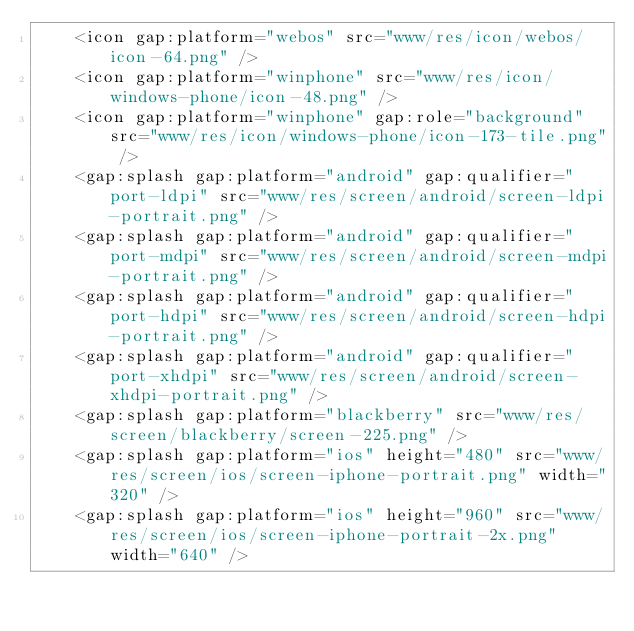<code> <loc_0><loc_0><loc_500><loc_500><_XML_>    <icon gap:platform="webos" src="www/res/icon/webos/icon-64.png" />
    <icon gap:platform="winphone" src="www/res/icon/windows-phone/icon-48.png" />
    <icon gap:platform="winphone" gap:role="background" src="www/res/icon/windows-phone/icon-173-tile.png" />
    <gap:splash gap:platform="android" gap:qualifier="port-ldpi" src="www/res/screen/android/screen-ldpi-portrait.png" />
    <gap:splash gap:platform="android" gap:qualifier="port-mdpi" src="www/res/screen/android/screen-mdpi-portrait.png" />
    <gap:splash gap:platform="android" gap:qualifier="port-hdpi" src="www/res/screen/android/screen-hdpi-portrait.png" />
    <gap:splash gap:platform="android" gap:qualifier="port-xhdpi" src="www/res/screen/android/screen-xhdpi-portrait.png" />
    <gap:splash gap:platform="blackberry" src="www/res/screen/blackberry/screen-225.png" />
    <gap:splash gap:platform="ios" height="480" src="www/res/screen/ios/screen-iphone-portrait.png" width="320" />
    <gap:splash gap:platform="ios" height="960" src="www/res/screen/ios/screen-iphone-portrait-2x.png" width="640" /></code> 